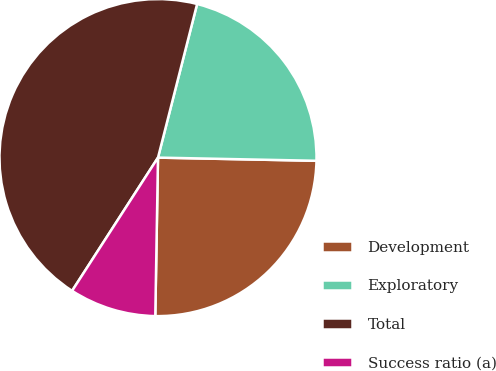Convert chart. <chart><loc_0><loc_0><loc_500><loc_500><pie_chart><fcel>Development<fcel>Exploratory<fcel>Total<fcel>Success ratio (a)<nl><fcel>24.95%<fcel>21.35%<fcel>44.85%<fcel>8.84%<nl></chart> 